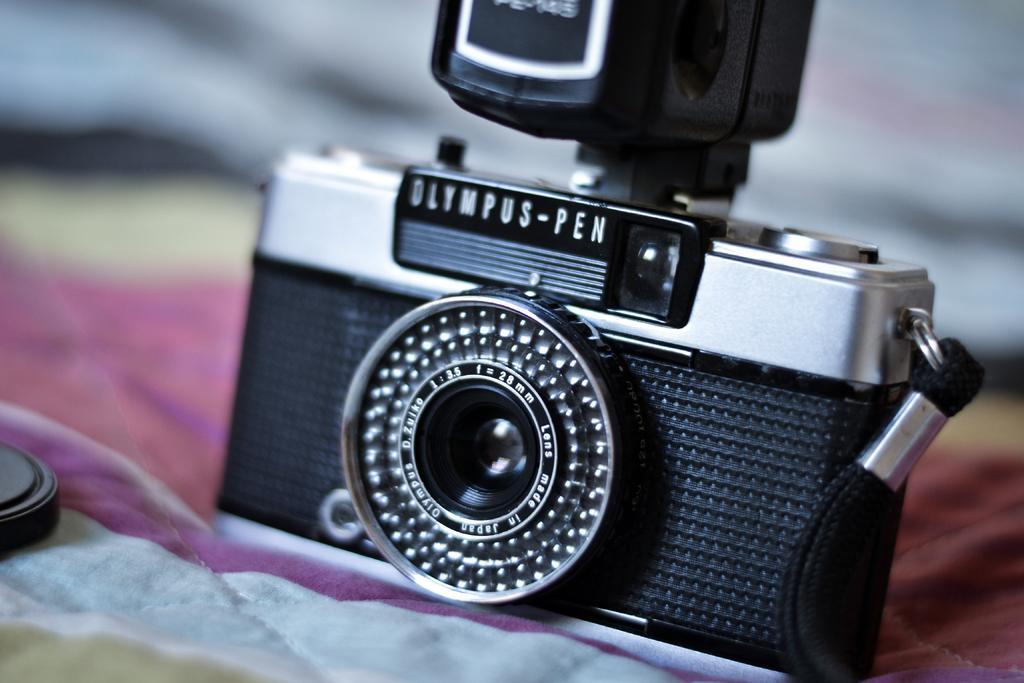How would you summarize this image in a sentence or two? In the center of the image a camera is present on cloth. In the background the image is blur. On the left side of the image an object is there. 